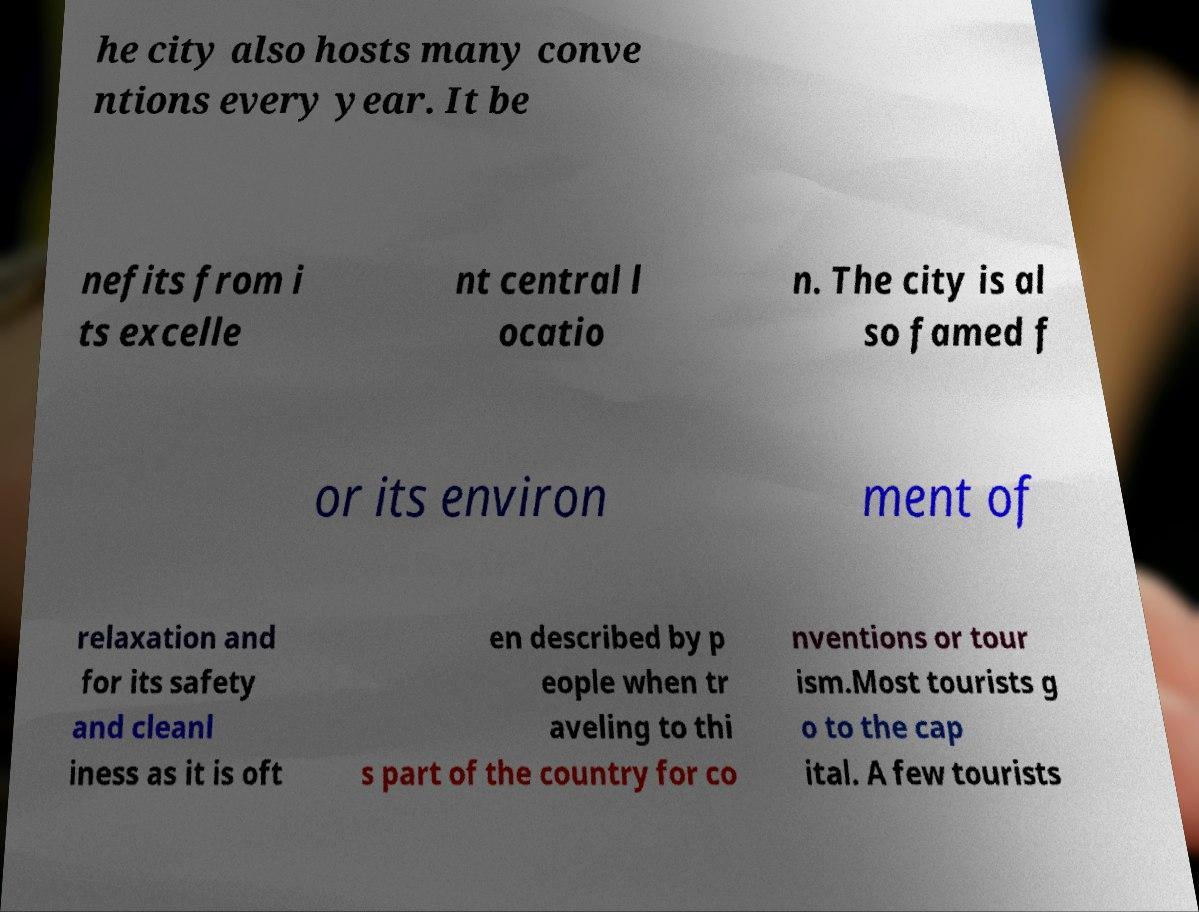Can you accurately transcribe the text from the provided image for me? he city also hosts many conve ntions every year. It be nefits from i ts excelle nt central l ocatio n. The city is al so famed f or its environ ment of relaxation and for its safety and cleanl iness as it is oft en described by p eople when tr aveling to thi s part of the country for co nventions or tour ism.Most tourists g o to the cap ital. A few tourists 